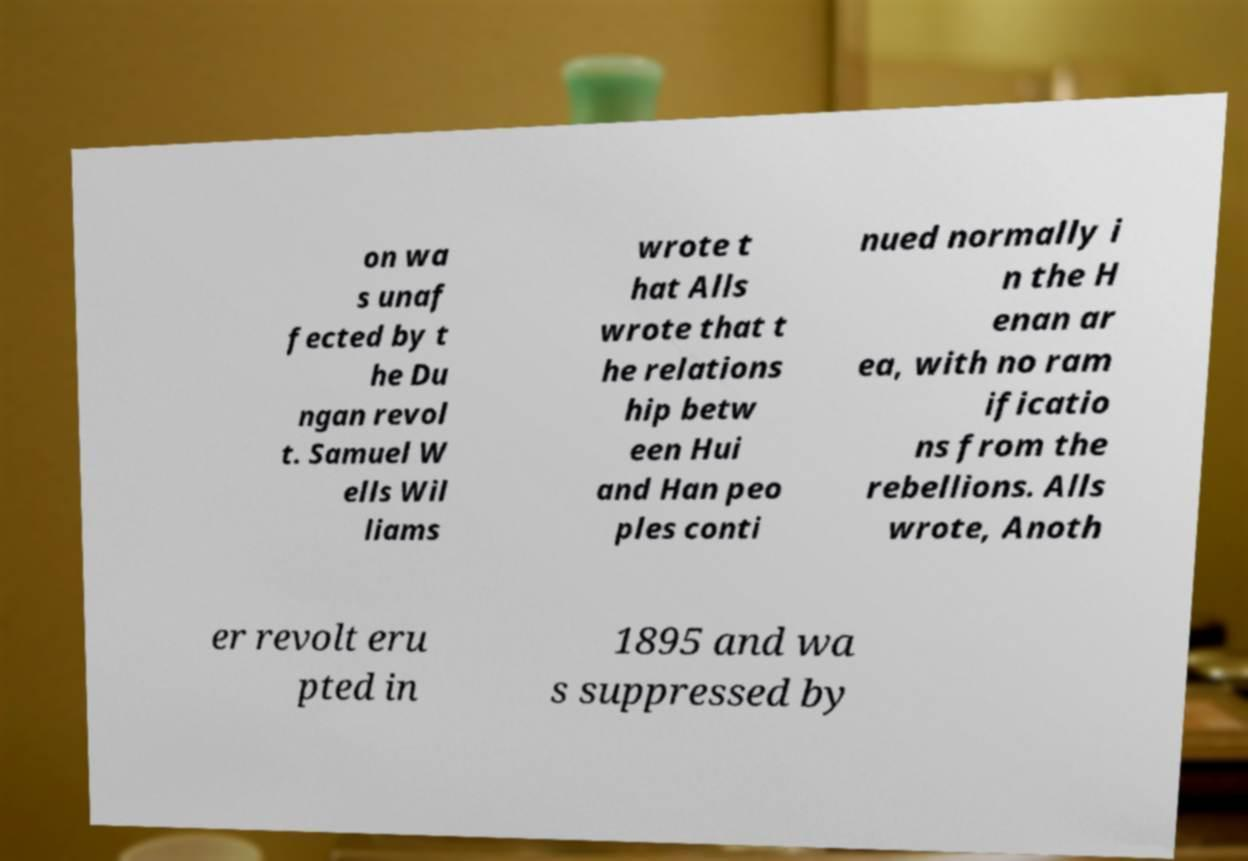Please identify and transcribe the text found in this image. on wa s unaf fected by t he Du ngan revol t. Samuel W ells Wil liams wrote t hat Alls wrote that t he relations hip betw een Hui and Han peo ples conti nued normally i n the H enan ar ea, with no ram ificatio ns from the rebellions. Alls wrote, Anoth er revolt eru pted in 1895 and wa s suppressed by 